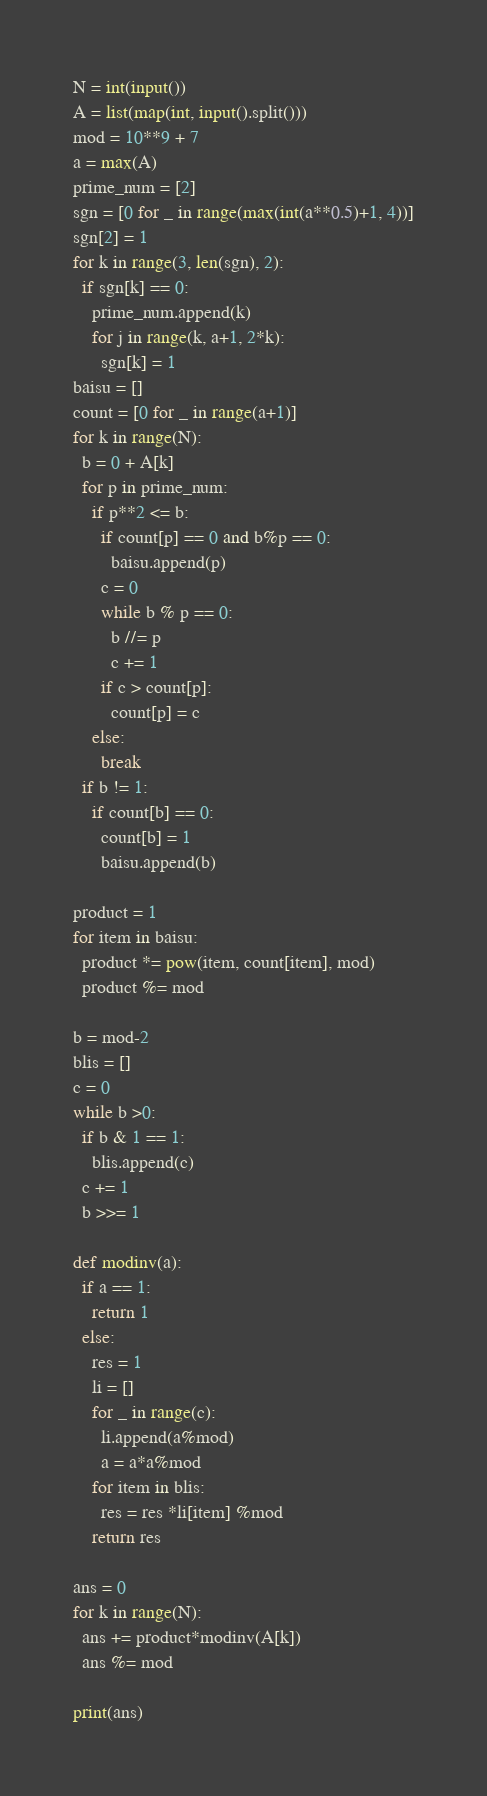Convert code to text. <code><loc_0><loc_0><loc_500><loc_500><_Python_>N = int(input())
A = list(map(int, input().split()))
mod = 10**9 + 7
a = max(A)
prime_num = [2]
sgn = [0 for _ in range(max(int(a**0.5)+1, 4))]
sgn[2] = 1
for k in range(3, len(sgn), 2):
  if sgn[k] == 0:
    prime_num.append(k)
    for j in range(k, a+1, 2*k):
      sgn[k] = 1
baisu = []
count = [0 for _ in range(a+1)]
for k in range(N):
  b = 0 + A[k]
  for p in prime_num:
    if p**2 <= b:
      if count[p] == 0 and b%p == 0:
        baisu.append(p)
      c = 0
      while b % p == 0:
        b //= p 
        c += 1 
      if c > count[p]:
        count[p] = c
    else:
      break
  if b != 1:
    if count[b] == 0:
      count[b] = 1
      baisu.append(b)

product = 1
for item in baisu:
  product *= pow(item, count[item], mod)
  product %= mod

b = mod-2
blis = []
c = 0
while b >0:
  if b & 1 == 1:
    blis.append(c)
  c += 1
  b >>= 1

def modinv(a):
  if a == 1:
    return 1
  else:
    res = 1
    li = []
    for _ in range(c):
      li.append(a%mod)
      a = a*a%mod
    for item in blis:
      res = res *li[item] %mod
    return res

ans = 0
for k in range(N):
  ans += product*modinv(A[k])
  ans %= mod

print(ans)</code> 